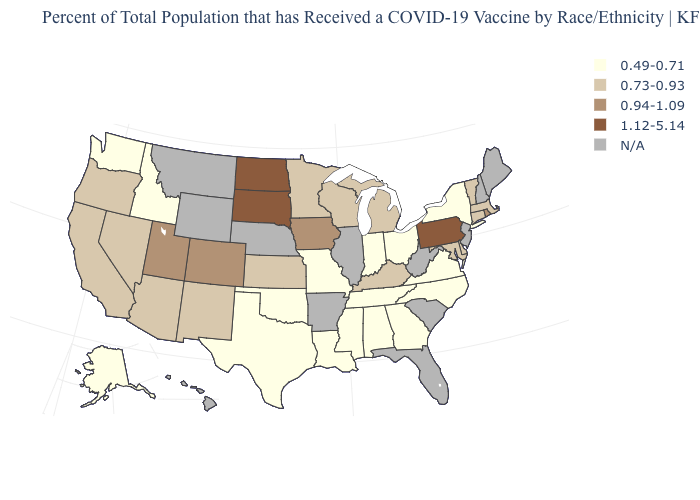Does Indiana have the highest value in the USA?
Quick response, please. No. Does the map have missing data?
Be succinct. Yes. Name the states that have a value in the range 0.73-0.93?
Answer briefly. Arizona, California, Connecticut, Delaware, Kansas, Kentucky, Maryland, Massachusetts, Michigan, Minnesota, Nevada, New Mexico, Oregon, Vermont, Wisconsin. What is the lowest value in states that border Wyoming?
Give a very brief answer. 0.49-0.71. What is the value of South Carolina?
Write a very short answer. N/A. Name the states that have a value in the range N/A?
Write a very short answer. Arkansas, Florida, Hawaii, Illinois, Maine, Montana, Nebraska, New Hampshire, New Jersey, South Carolina, West Virginia, Wyoming. Name the states that have a value in the range 0.73-0.93?
Concise answer only. Arizona, California, Connecticut, Delaware, Kansas, Kentucky, Maryland, Massachusetts, Michigan, Minnesota, Nevada, New Mexico, Oregon, Vermont, Wisconsin. Does North Dakota have the lowest value in the USA?
Quick response, please. No. What is the value of North Dakota?
Concise answer only. 1.12-5.14. Does the map have missing data?
Be succinct. Yes. What is the value of South Carolina?
Keep it brief. N/A. Does South Dakota have the highest value in the MidWest?
Concise answer only. Yes. Does the first symbol in the legend represent the smallest category?
Concise answer only. Yes. 